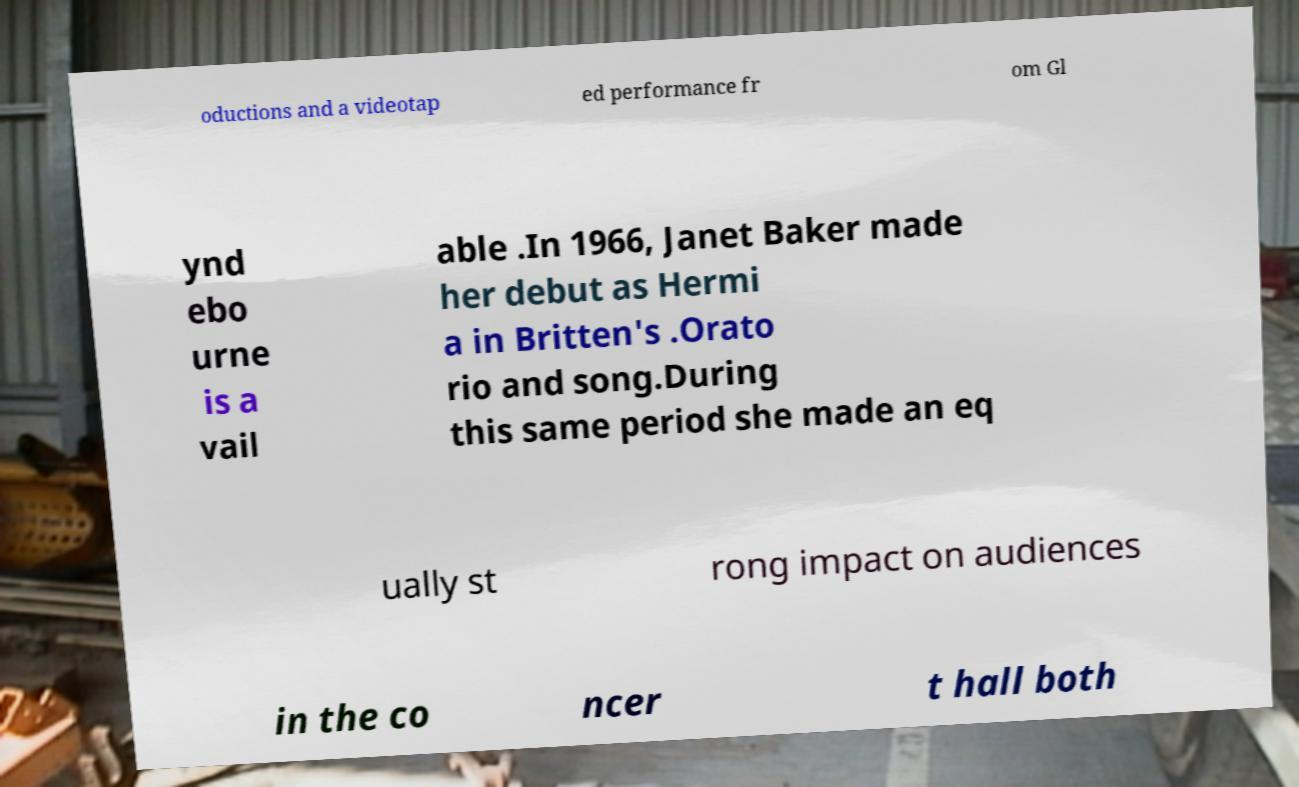Could you extract and type out the text from this image? oductions and a videotap ed performance fr om Gl ynd ebo urne is a vail able .In 1966, Janet Baker made her debut as Hermi a in Britten's .Orato rio and song.During this same period she made an eq ually st rong impact on audiences in the co ncer t hall both 